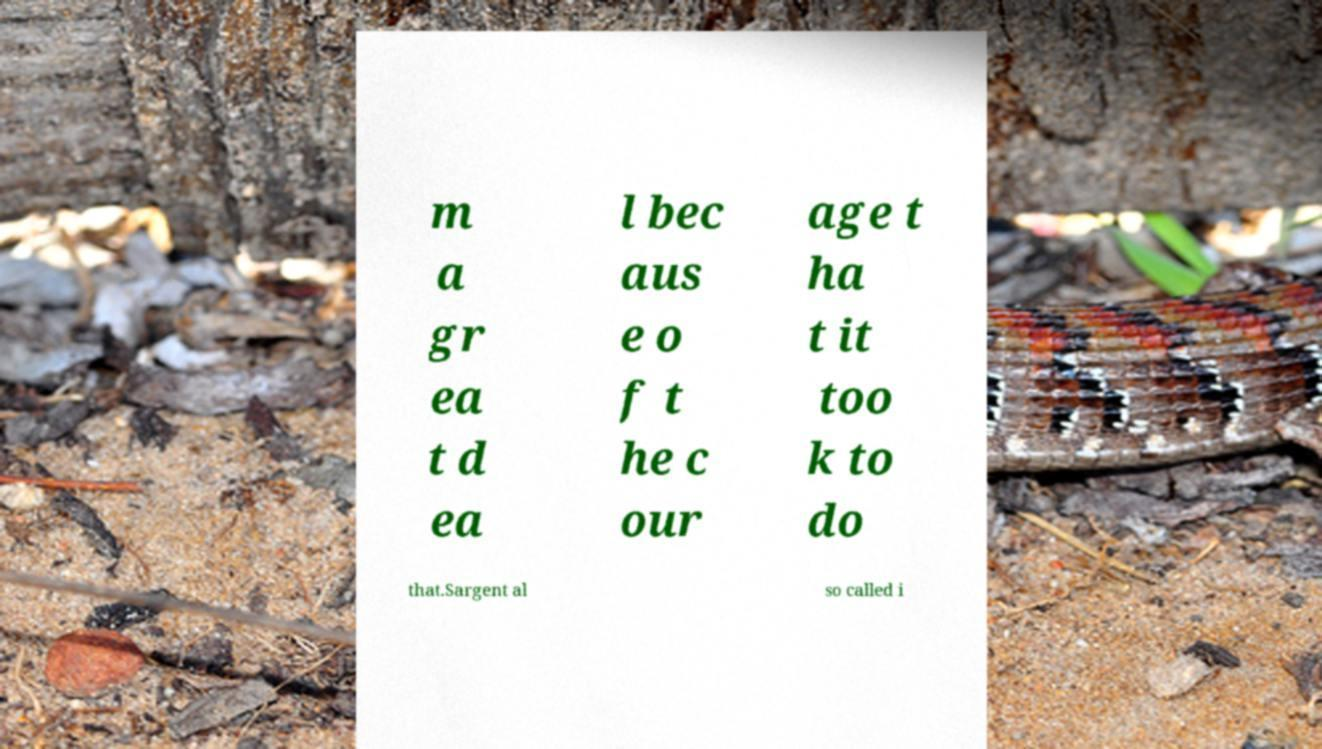Can you read and provide the text displayed in the image?This photo seems to have some interesting text. Can you extract and type it out for me? m a gr ea t d ea l bec aus e o f t he c our age t ha t it too k to do that.Sargent al so called i 